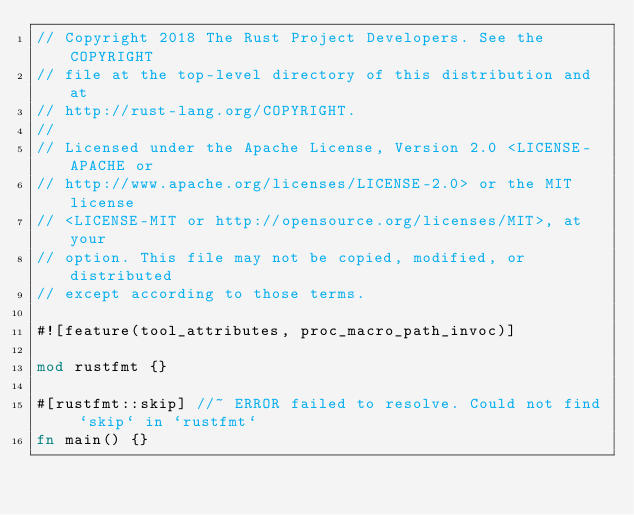<code> <loc_0><loc_0><loc_500><loc_500><_Rust_>// Copyright 2018 The Rust Project Developers. See the COPYRIGHT
// file at the top-level directory of this distribution and at
// http://rust-lang.org/COPYRIGHT.
//
// Licensed under the Apache License, Version 2.0 <LICENSE-APACHE or
// http://www.apache.org/licenses/LICENSE-2.0> or the MIT license
// <LICENSE-MIT or http://opensource.org/licenses/MIT>, at your
// option. This file may not be copied, modified, or distributed
// except according to those terms.

#![feature(tool_attributes, proc_macro_path_invoc)]

mod rustfmt {}

#[rustfmt::skip] //~ ERROR failed to resolve. Could not find `skip` in `rustfmt`
fn main() {}
</code> 